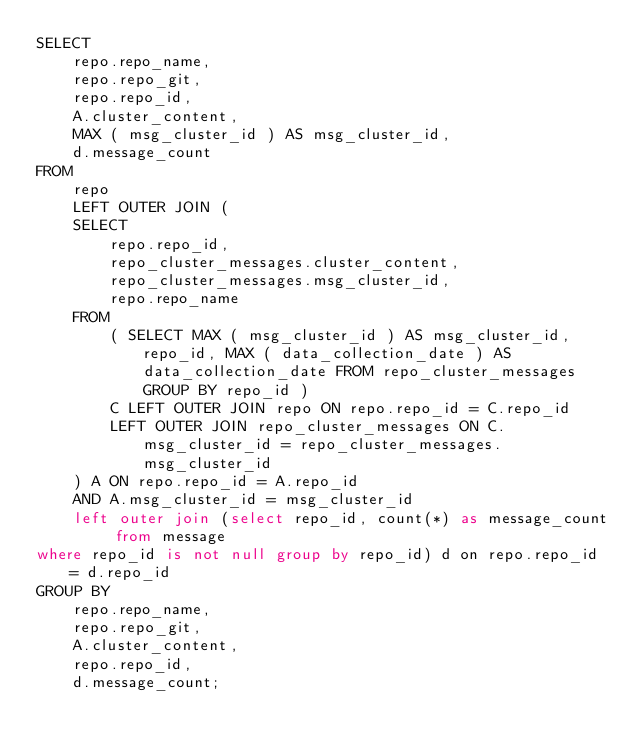Convert code to text. <code><loc_0><loc_0><loc_500><loc_500><_SQL_>SELECT
    repo.repo_name,
    repo.repo_git,
    repo.repo_id,
    A.cluster_content,
    MAX ( msg_cluster_id ) AS msg_cluster_id, 
    d.message_count 
FROM
    repo
    LEFT OUTER JOIN (
    SELECT
        repo.repo_id,
        repo_cluster_messages.cluster_content,
        repo_cluster_messages.msg_cluster_id,
        repo.repo_name 
    FROM
        ( SELECT MAX ( msg_cluster_id ) AS msg_cluster_id, repo_id, MAX ( data_collection_date ) AS data_collection_date FROM repo_cluster_messages GROUP BY repo_id )
        C LEFT OUTER JOIN repo ON repo.repo_id = C.repo_id
        LEFT OUTER JOIN repo_cluster_messages ON C.msg_cluster_id = repo_cluster_messages.msg_cluster_id 
    ) A ON repo.repo_id = A.repo_id 
    AND A.msg_cluster_id = msg_cluster_id 
    left outer join (select repo_id, count(*) as message_count from message 
where repo_id is not null group by repo_id) d on repo.repo_id = d.repo_id 
GROUP BY
    repo.repo_name,
    repo.repo_git,
    A.cluster_content,
    repo.repo_id,
    d.message_count;</code> 